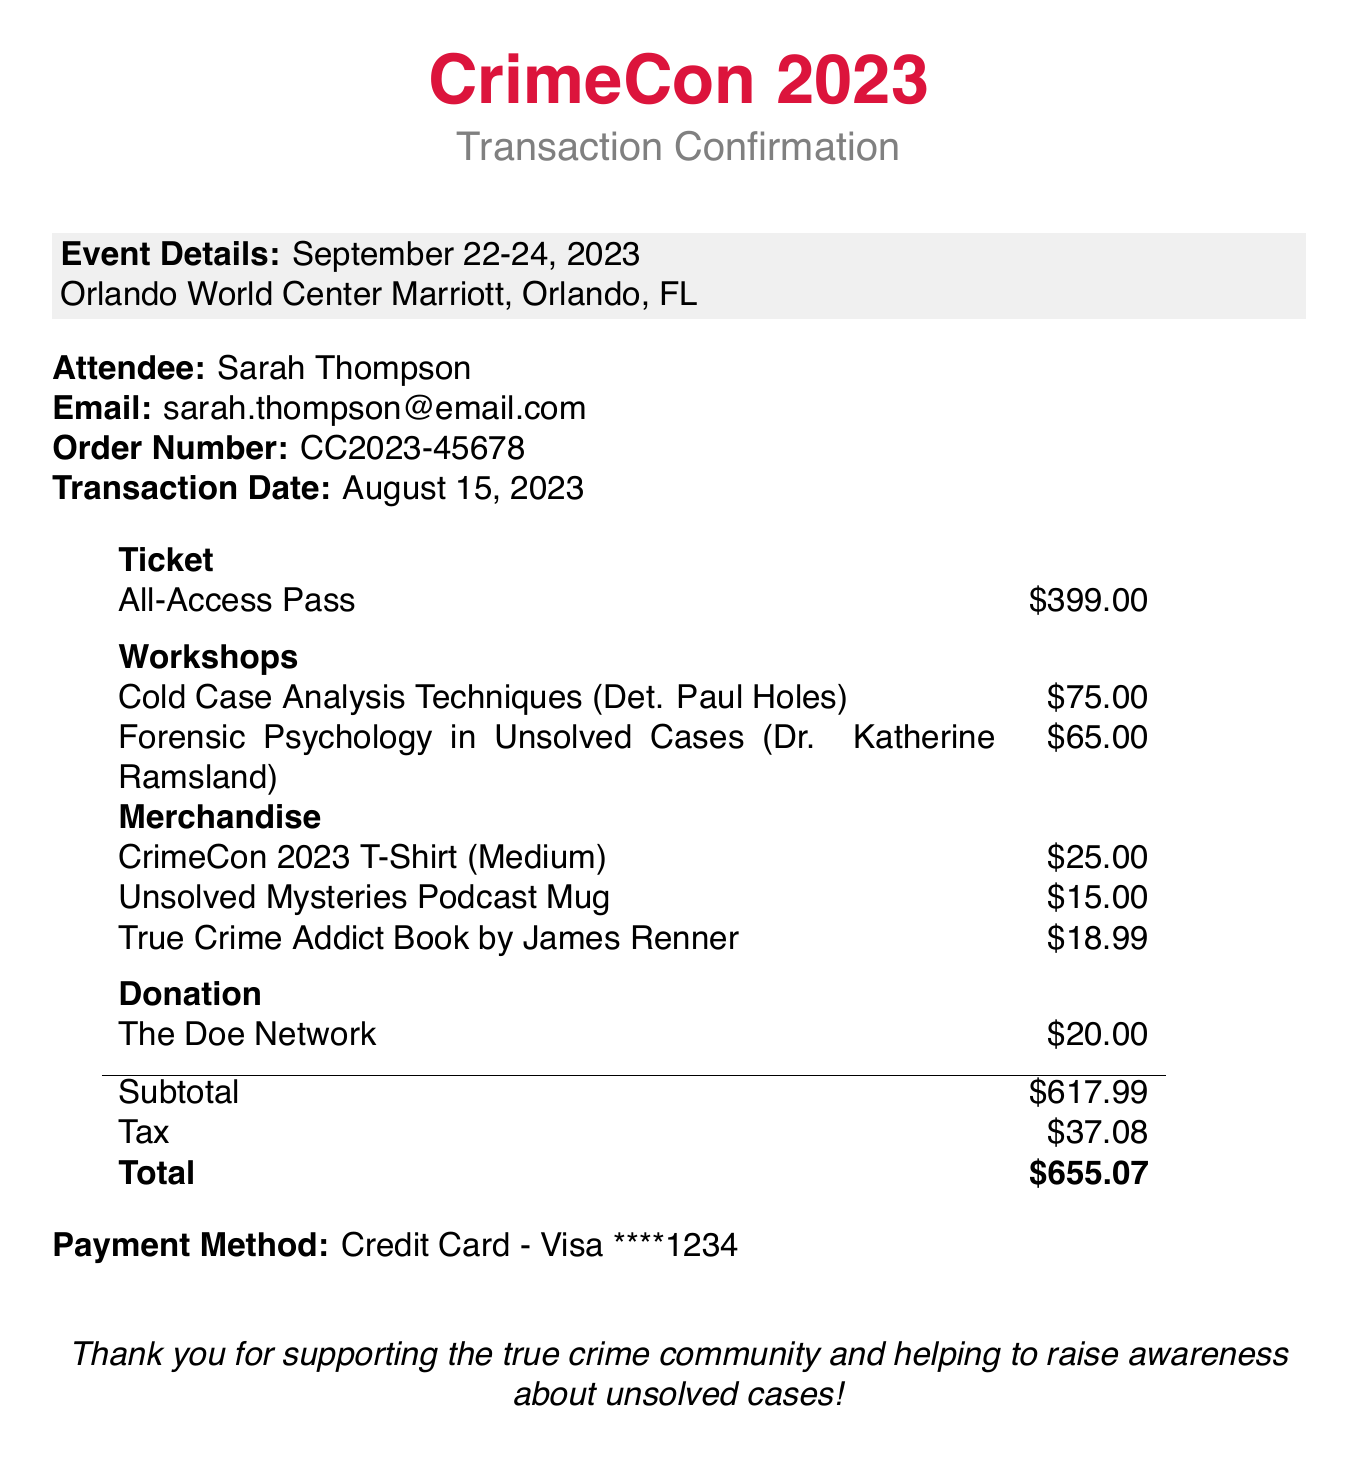what is the event name? The event name is clearly stated at the top of the document.
Answer: CrimeCon 2023 what is the date of the event? The date of the event is indicated in the event details section.
Answer: September 22-24, 2023 who is the attendee? The attendee's name is listed under the attendee section of the document.
Answer: Sarah Thompson what is the total amount paid? The total amount appears at the bottom of the transaction details, reflecting all charges.
Answer: 655.07 how many workshops did the attendee register for? The number of workshops can be counted from the workshops section in the document.
Answer: 2 what is the fee for the "Cold Case Analysis Techniques" workshop? The fee for each workshop is provided alongside the workshop name and instructor.
Answer: 75.00 what payment method was used? The payment method is explicitly mentioned at the bottom of the document.
Answer: Credit Card - Visa ****1234 what organization received the donation? The organization that received the donation is noted in the donation section.
Answer: The Doe Network which merchandise item has the lowest price? To find the cheapest item, we compare the prices of all merchandise listed.
Answer: Unsolved Mysteries Podcast Mug what is the subtotal before tax? The subtotal is located in the financial summary part of the document.
Answer: 617.99 